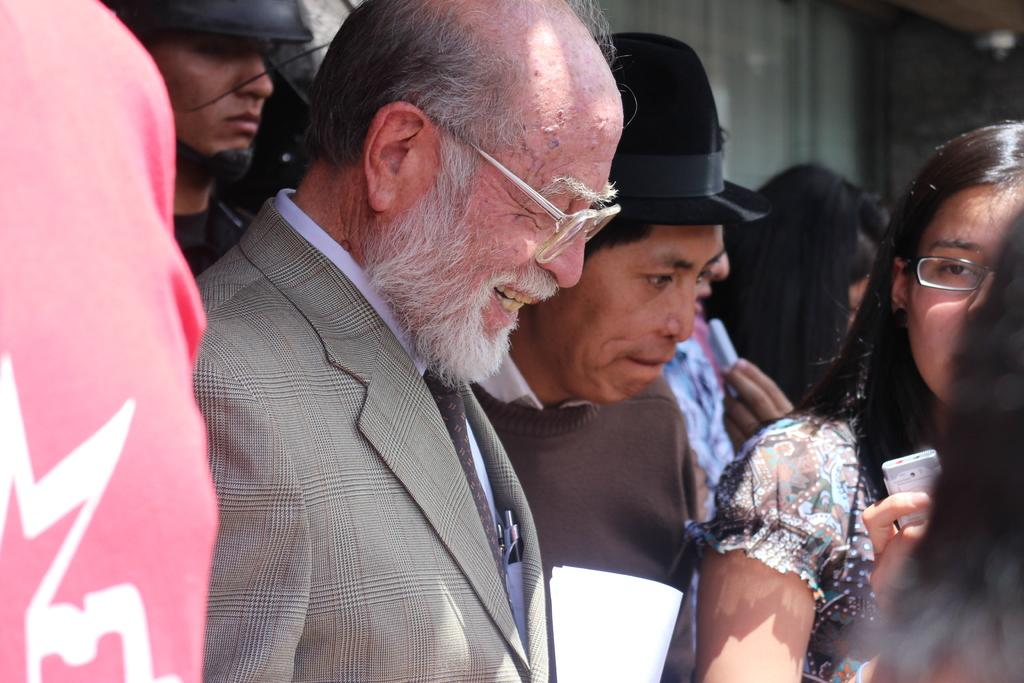What can be seen in the image? There is a group of people in the image. Can you describe any specific individuals in the group? A man is present among the group. What is the man doing in the image? The man is smiling. How would you describe the background of the image? The background of the image is blurry. How many pets are visible in the image? There are no pets present in the image. What type of road can be seen in the background of the image? There is no road visible in the image; the background is blurry. 